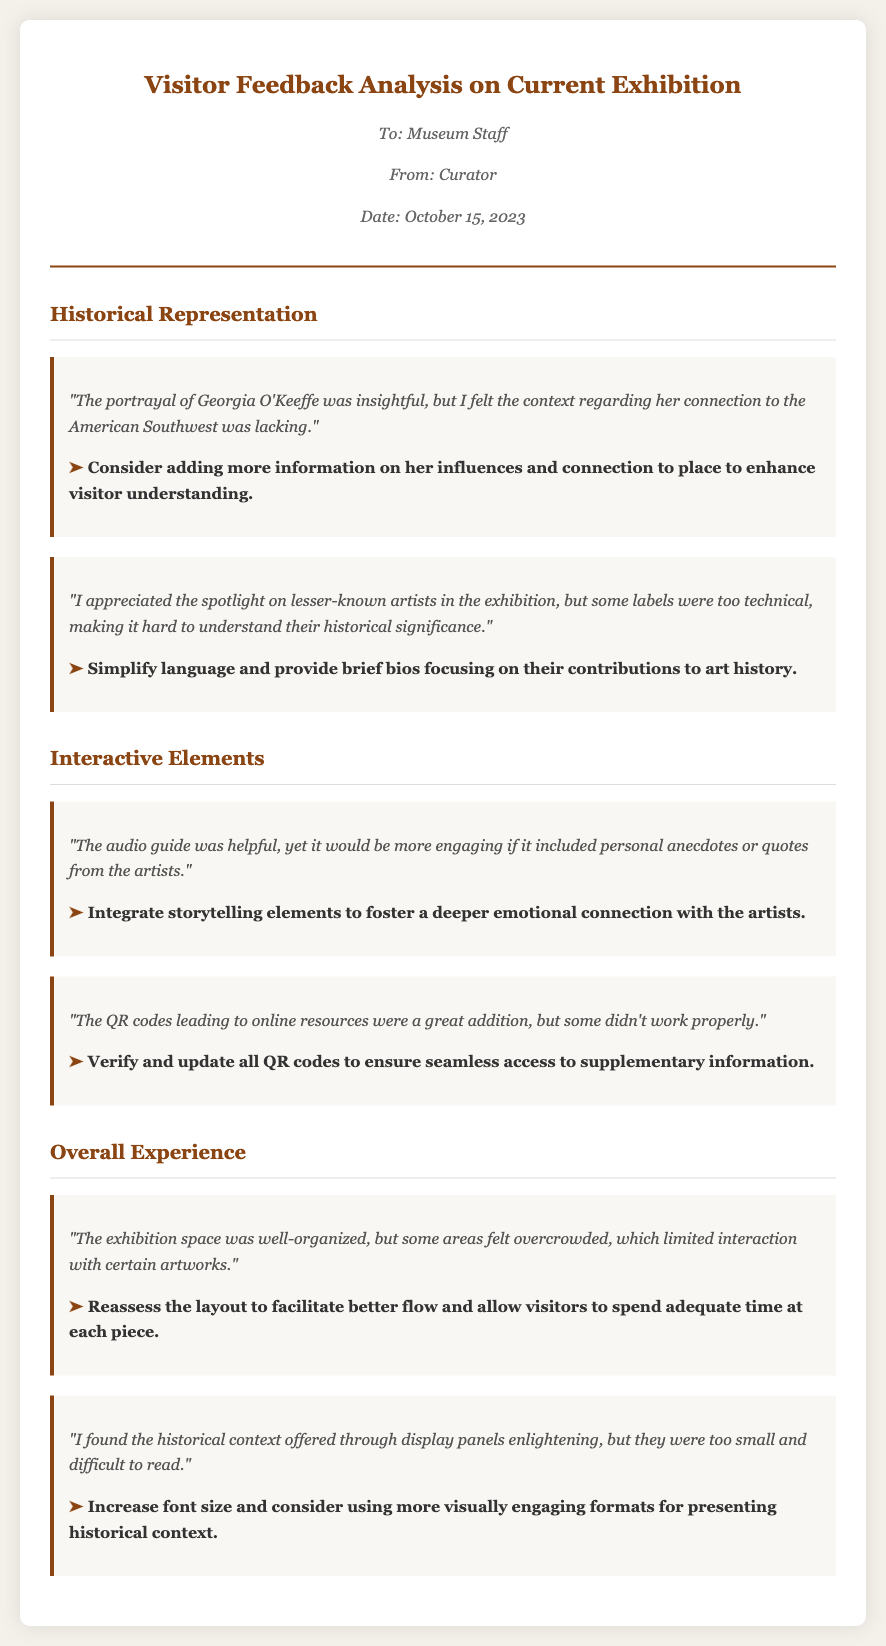What was the date of the memo? The date of the memo is stated in the document as October 15, 2023.
Answer: October 15, 2023 Who is the author of the memo? The author of the memo is listed as Curator in the document.
Answer: Curator What was highlighted about Georgia O'Keeffe? The memo notes that the portrayal of Georgia O'Keeffe was insightful, but lacking in context regarding her connection to the American Southwest.
Answer: Insightful, lacking context What suggestion was made for the audio guide? The suggestion for the audio guide was to include personal anecdotes or quotes from the artists.
Answer: Include personal anecdotes How did visitors feel about the historical context through display panels? Visitors found the historical context enlightening, but the panels were too small and difficult to read.
Answer: Enlightening, too small What aspect of visitor experience was described as overcrowded? The memo mentions that some areas of the exhibition space felt overcrowded, limiting interaction with artworks.
Answer: Areas of the exhibition space What was mentioned about the QR codes? It was noted that some QR codes didn't work properly.
Answer: Some didn't work properly What is a suggested improvement for the layout of the exhibition? The suggestion was to reassess the layout to facilitate better flow and interaction with artworks.
Answer: Reassess the layout How were the labels for lesser-known artists described? The labels were described as too technical, making it hard to understand their historical significance.
Answer: Too technical What was suggested to improve the historical context presentation? The suggestion was to increase font size and consider using more visually engaging formats.
Answer: Increase font size 